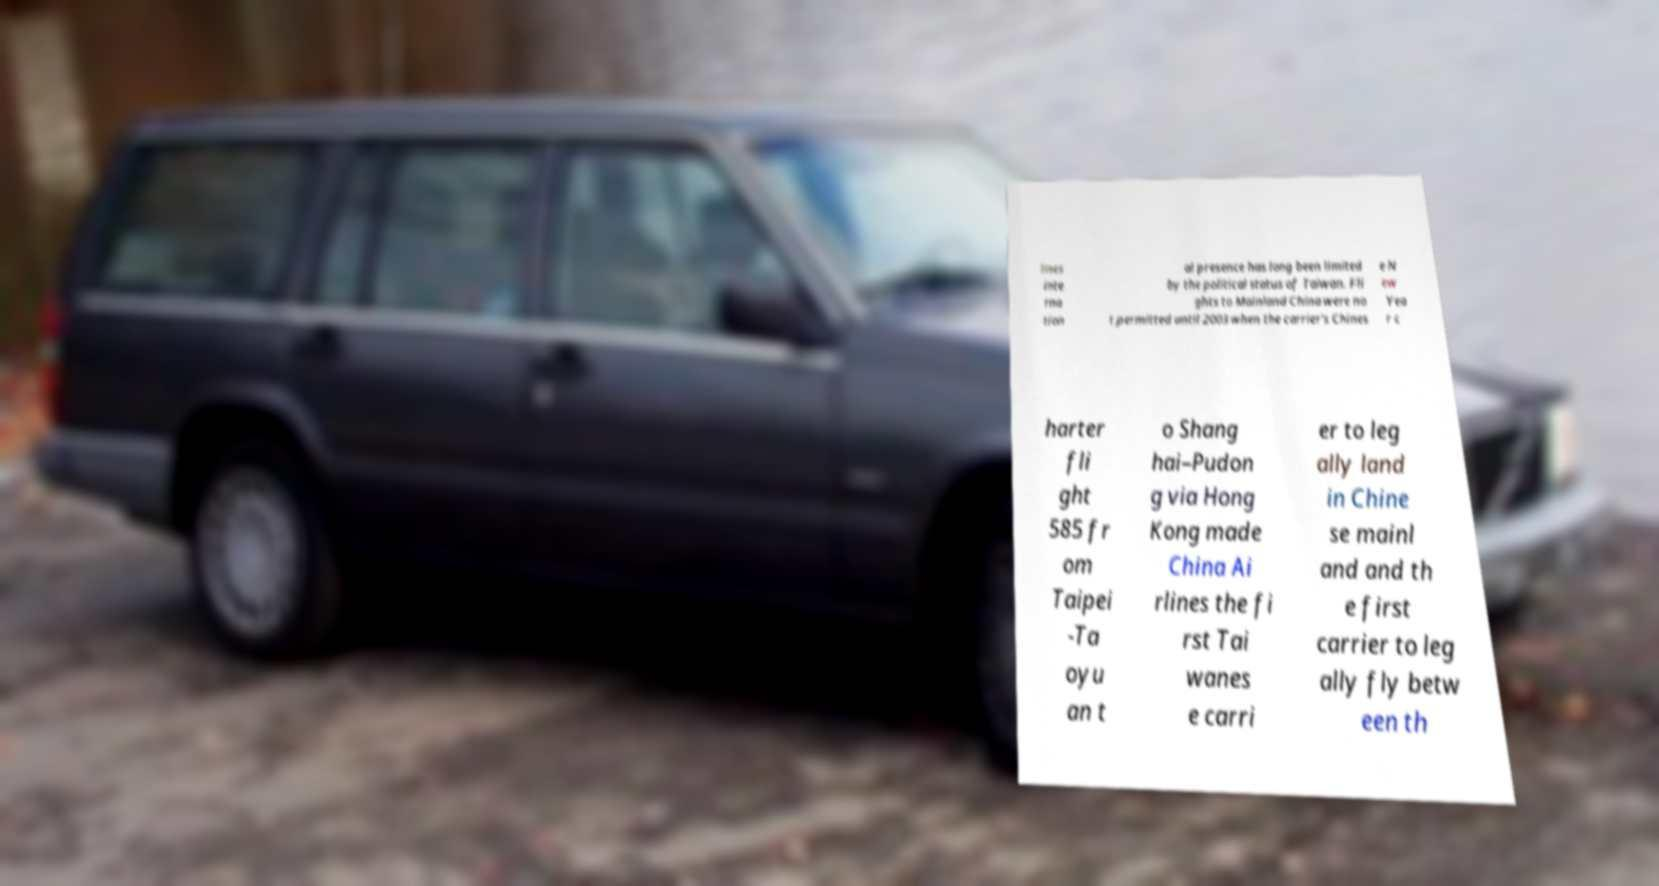Please read and relay the text visible in this image. What does it say? lines inte rna tion al presence has long been limited by the political status of Taiwan. Fli ghts to Mainland China were no t permitted until 2003 when the carrier's Chines e N ew Yea r c harter fli ght 585 fr om Taipei -Ta oyu an t o Shang hai–Pudon g via Hong Kong made China Ai rlines the fi rst Tai wanes e carri er to leg ally land in Chine se mainl and and th e first carrier to leg ally fly betw een th 